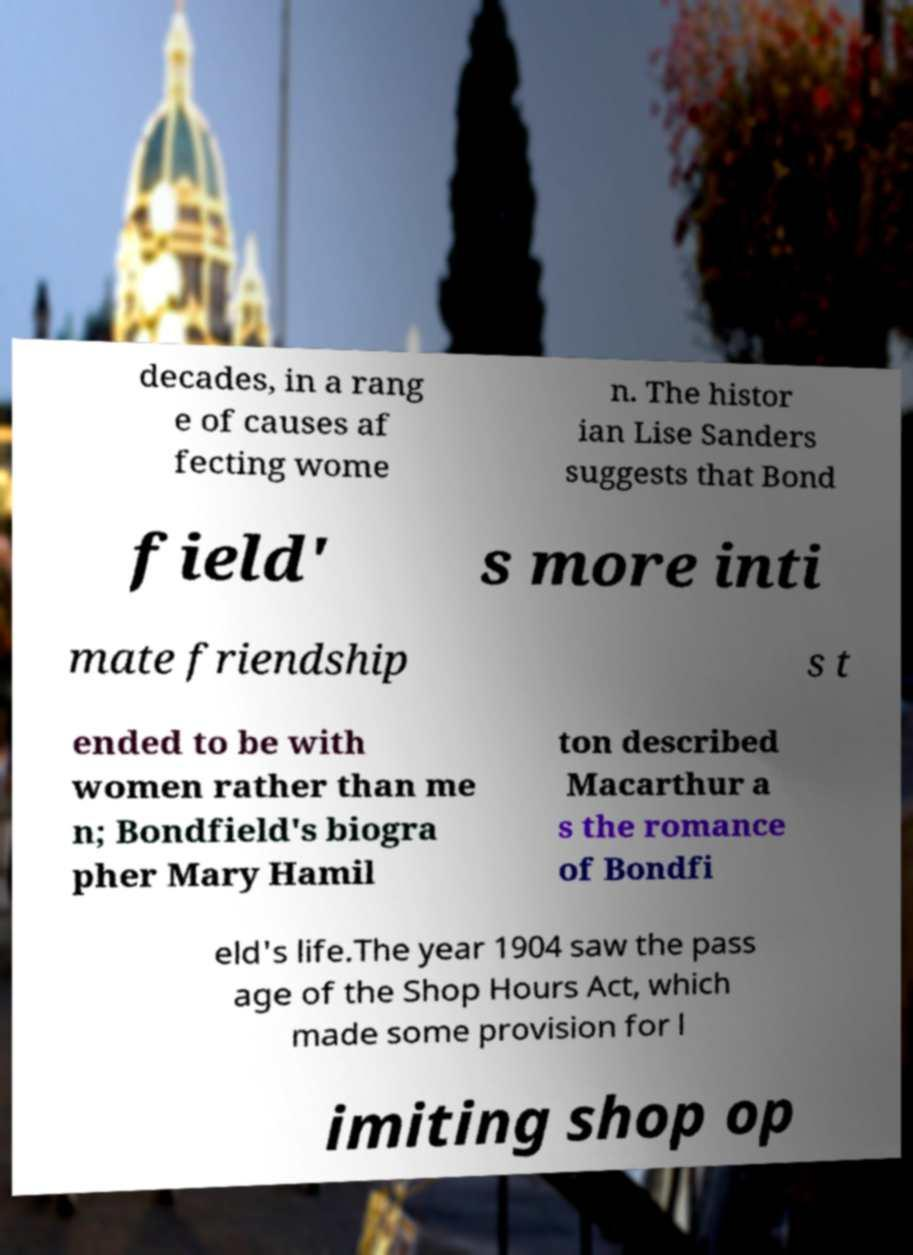Please read and relay the text visible in this image. What does it say? decades, in a rang e of causes af fecting wome n. The histor ian Lise Sanders suggests that Bond field' s more inti mate friendship s t ended to be with women rather than me n; Bondfield's biogra pher Mary Hamil ton described Macarthur a s the romance of Bondfi eld's life.The year 1904 saw the pass age of the Shop Hours Act, which made some provision for l imiting shop op 